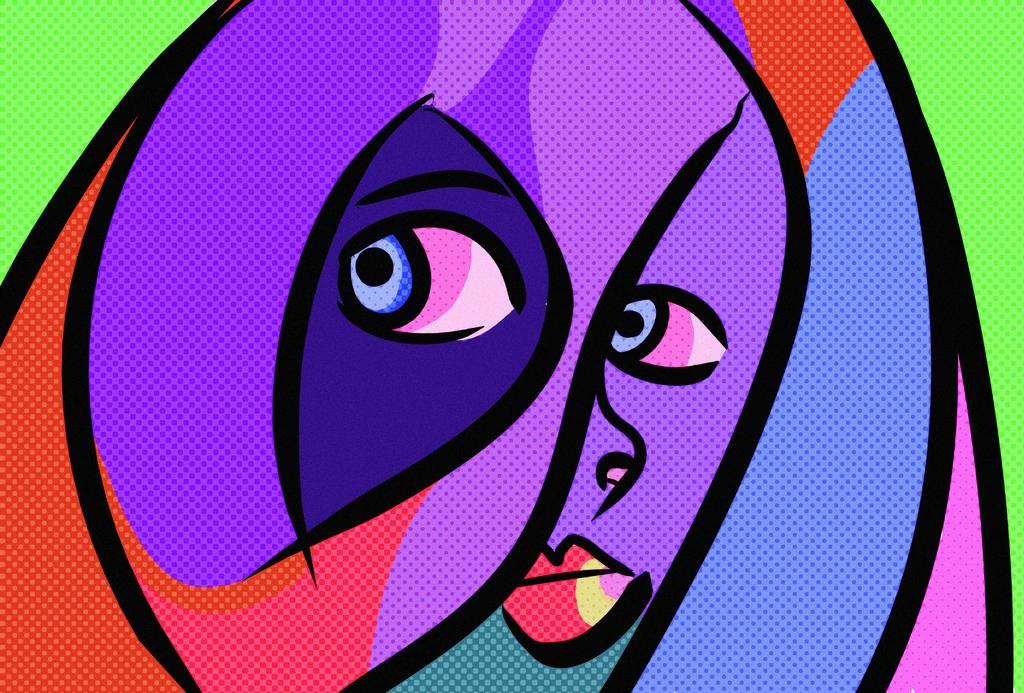What type of image is being described? The image is a digital art piece. What is the main subject of the image? There is a picture of a woman in the image. How is the woman depicted in the image? The woman is depicted with different colors. What type of agreement is being discussed in the image? There is no agreement being discussed in the image; it is a digital art piece featuring a woman depicted with different colors. 